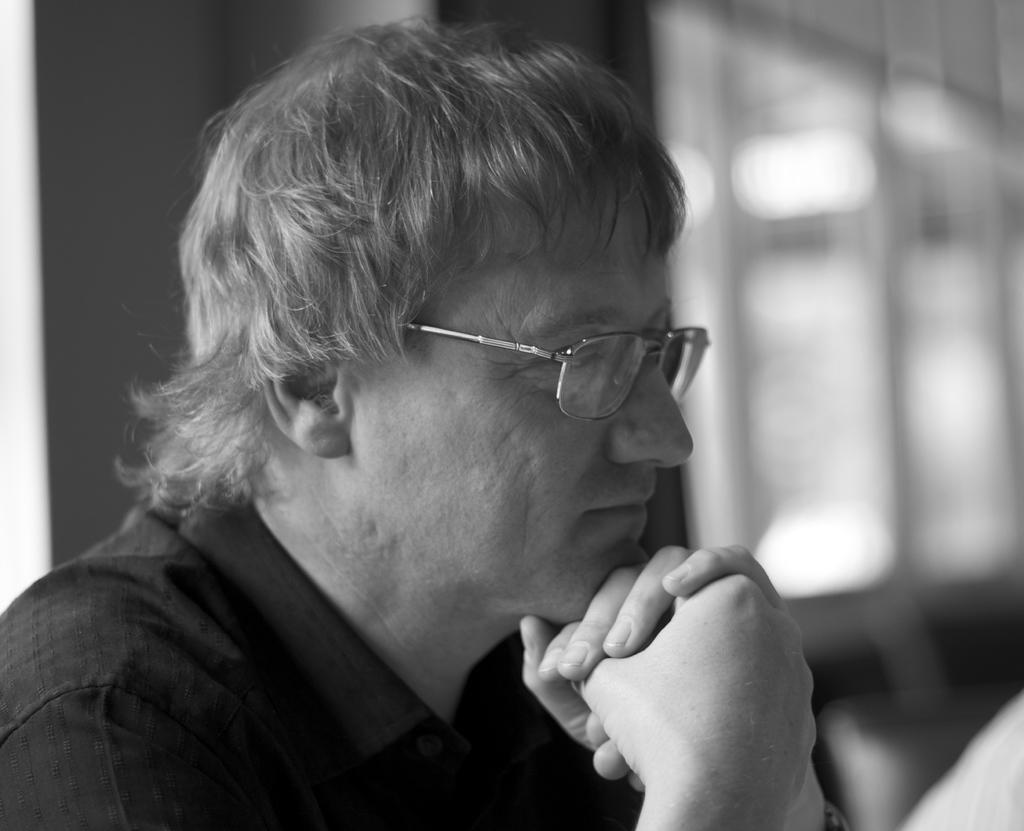What is the color scheme of the image? The image is black and white. Who is present in the image? There is a man in the image. What is the man wearing on his eyes? The man is wearing goggles on his eyes. Can you describe the background of the image? The background of the image is blurred, and there is a wall, windows, and objects visible. What type of horn can be heard in the image? There is no horn present in the image, and therefore no sound can be heard. What is the man trying to make in the image? The image does not provide information about the man's actions or intentions, so it cannot be determined what he is trying to make. 